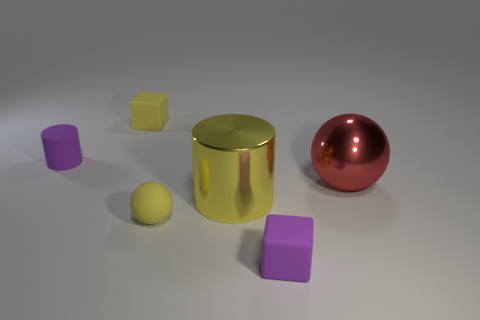There is a large metal object right of the purple cube in front of the purple matte cylinder; what is its shape?
Keep it short and to the point. Sphere. What number of yellow objects are either big spheres or tiny matte things?
Make the answer very short. 2. What color is the shiny cylinder?
Keep it short and to the point. Yellow. Do the purple cylinder and the metal cylinder have the same size?
Your answer should be very brief. No. Is there anything else that has the same shape as the big red object?
Ensure brevity in your answer.  Yes. Does the small ball have the same material as the small purple thing behind the shiny sphere?
Keep it short and to the point. Yes. There is a tiny matte thing to the left of the tiny yellow matte cube; is it the same color as the large ball?
Offer a very short reply. No. What number of small things are both behind the purple matte cylinder and on the right side of the yellow block?
Keep it short and to the point. 0. What number of other things are there of the same material as the red sphere
Provide a short and direct response. 1. Does the sphere on the right side of the purple matte block have the same material as the small cylinder?
Provide a short and direct response. No. 